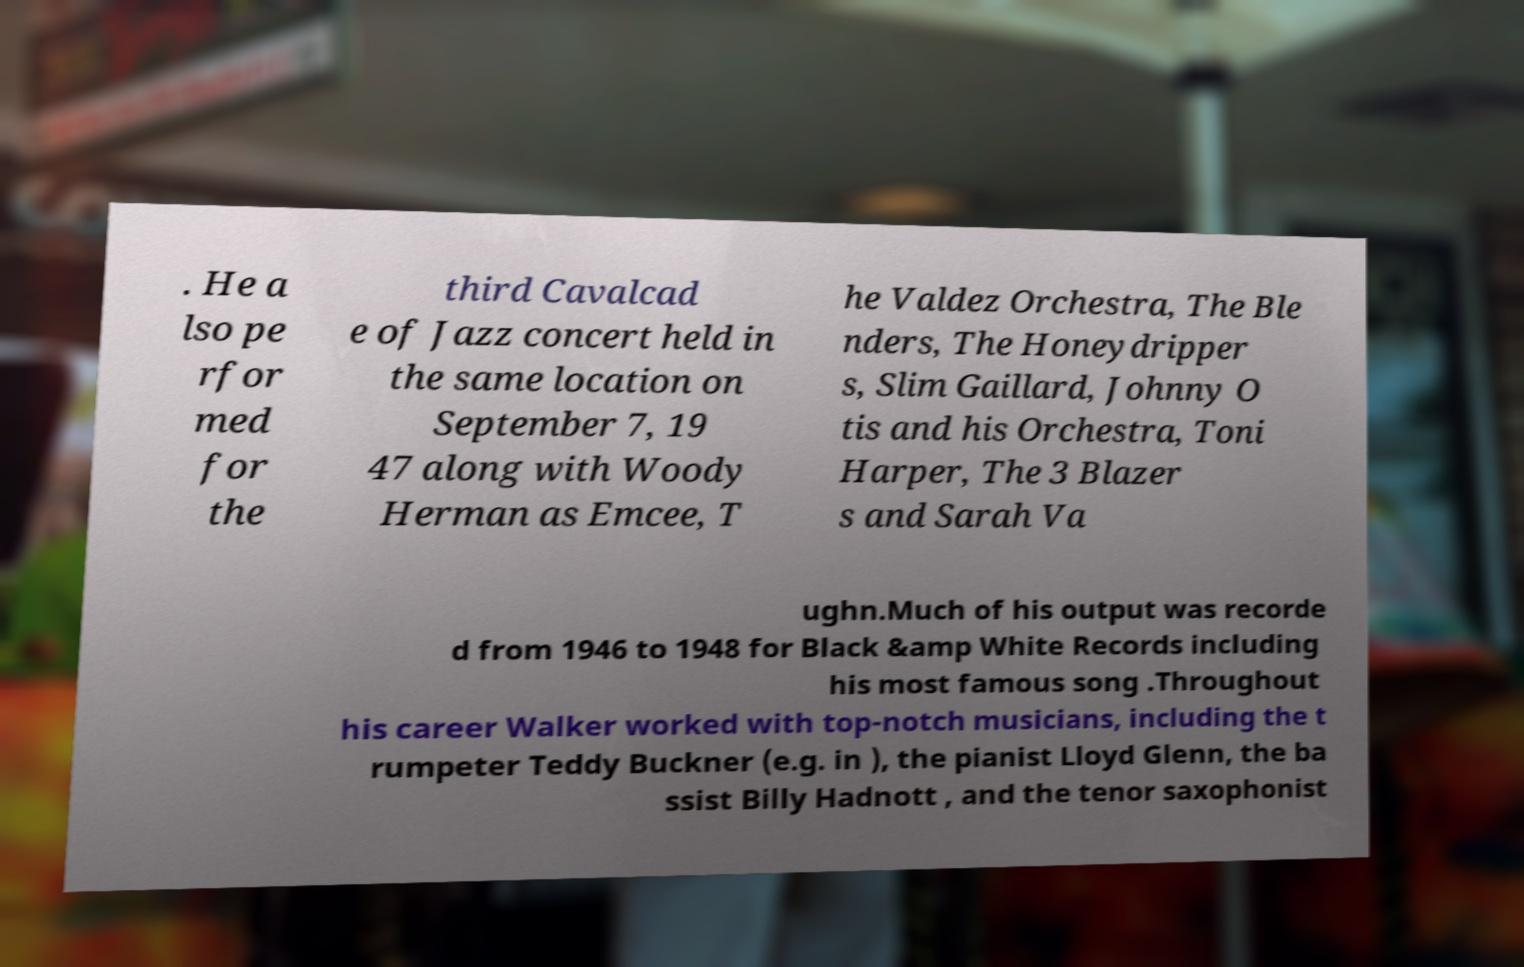Could you assist in decoding the text presented in this image and type it out clearly? . He a lso pe rfor med for the third Cavalcad e of Jazz concert held in the same location on September 7, 19 47 along with Woody Herman as Emcee, T he Valdez Orchestra, The Ble nders, The Honeydripper s, Slim Gaillard, Johnny O tis and his Orchestra, Toni Harper, The 3 Blazer s and Sarah Va ughn.Much of his output was recorde d from 1946 to 1948 for Black &amp White Records including his most famous song .Throughout his career Walker worked with top-notch musicians, including the t rumpeter Teddy Buckner (e.g. in ), the pianist Lloyd Glenn, the ba ssist Billy Hadnott , and the tenor saxophonist 